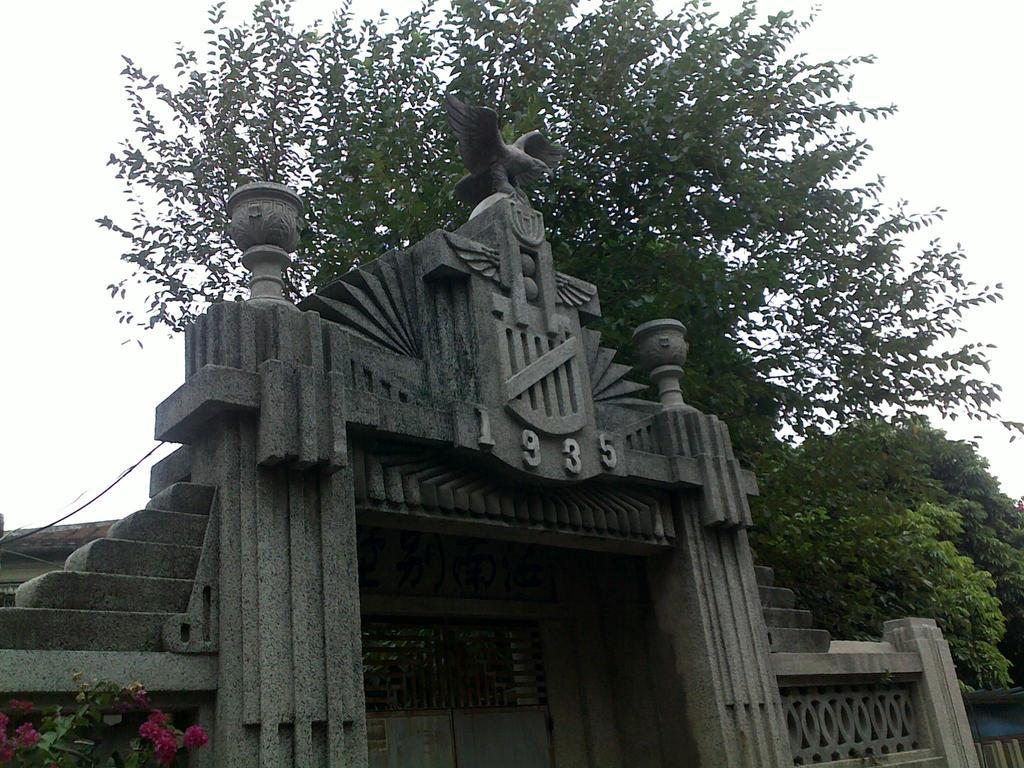<image>
Relay a brief, clear account of the picture shown. a large stone arch with an eagle over the year 1935 